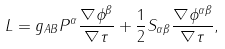<formula> <loc_0><loc_0><loc_500><loc_500>L = g _ { A B } P ^ { \alpha } \frac { \nabla \phi ^ { \beta } } { \nabla \tau } + \frac { 1 } { 2 } S _ { \alpha \beta } \frac { \nabla \phi ^ { \alpha \beta } } { \nabla \tau } ,</formula> 